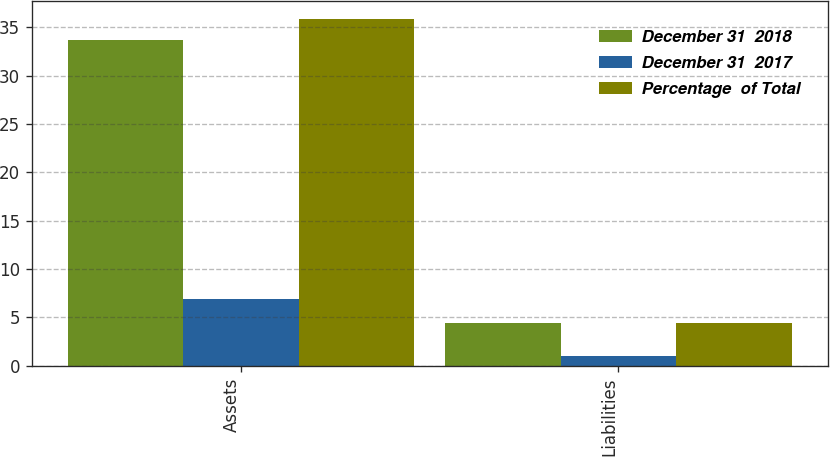Convert chart. <chart><loc_0><loc_0><loc_500><loc_500><stacked_bar_chart><ecel><fcel>Assets<fcel>Liabilities<nl><fcel>December 31  2018<fcel>33.7<fcel>4.4<nl><fcel>December 31  2017<fcel>6.9<fcel>1<nl><fcel>Percentage  of Total<fcel>35.9<fcel>4.4<nl></chart> 